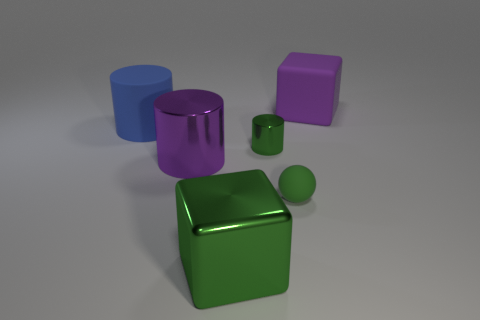Add 3 tiny green balls. How many objects exist? 9 Subtract all cubes. How many objects are left? 4 Add 2 big shiny cylinders. How many big shiny cylinders are left? 3 Add 2 big purple objects. How many big purple objects exist? 4 Subtract 1 purple cylinders. How many objects are left? 5 Subtract all green metallic cylinders. Subtract all metal cylinders. How many objects are left? 3 